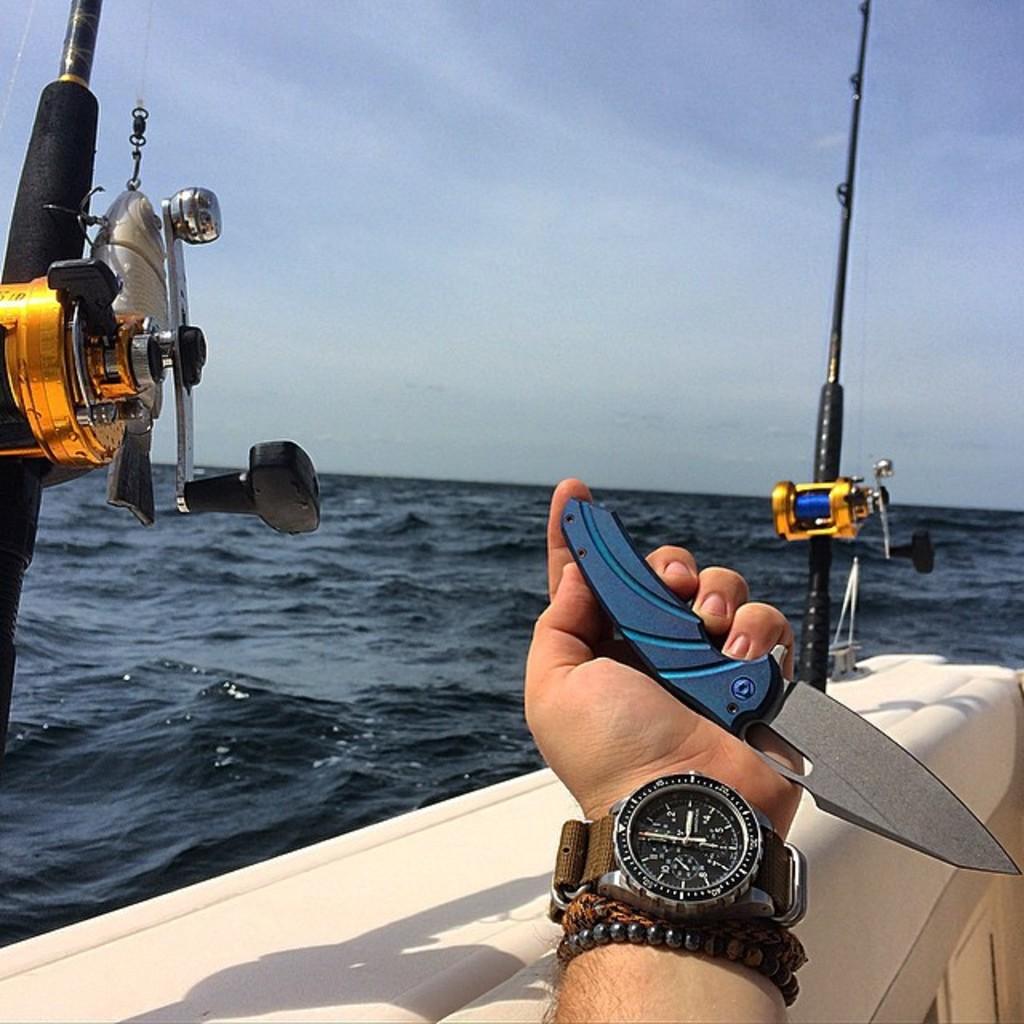What time does the watch indicate?
Make the answer very short. 3:00. 